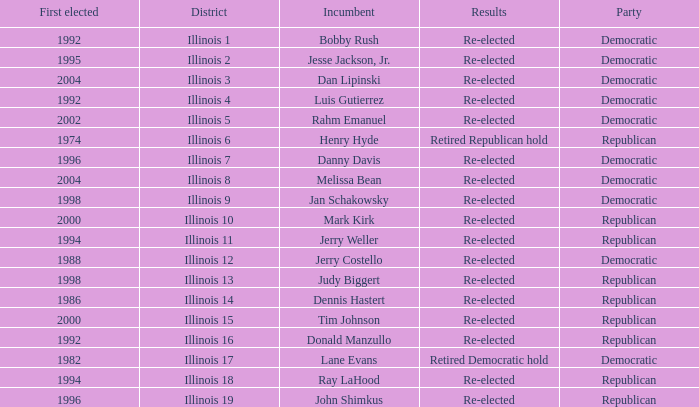What is Illinois 13 District's Party? Republican. 